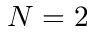Convert formula to latex. <formula><loc_0><loc_0><loc_500><loc_500>N = 2</formula> 